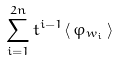Convert formula to latex. <formula><loc_0><loc_0><loc_500><loc_500>\sum _ { i = 1 } ^ { 2 n } t ^ { i - 1 } \langle \, \varphi _ { w _ { i } } \, \rangle</formula> 